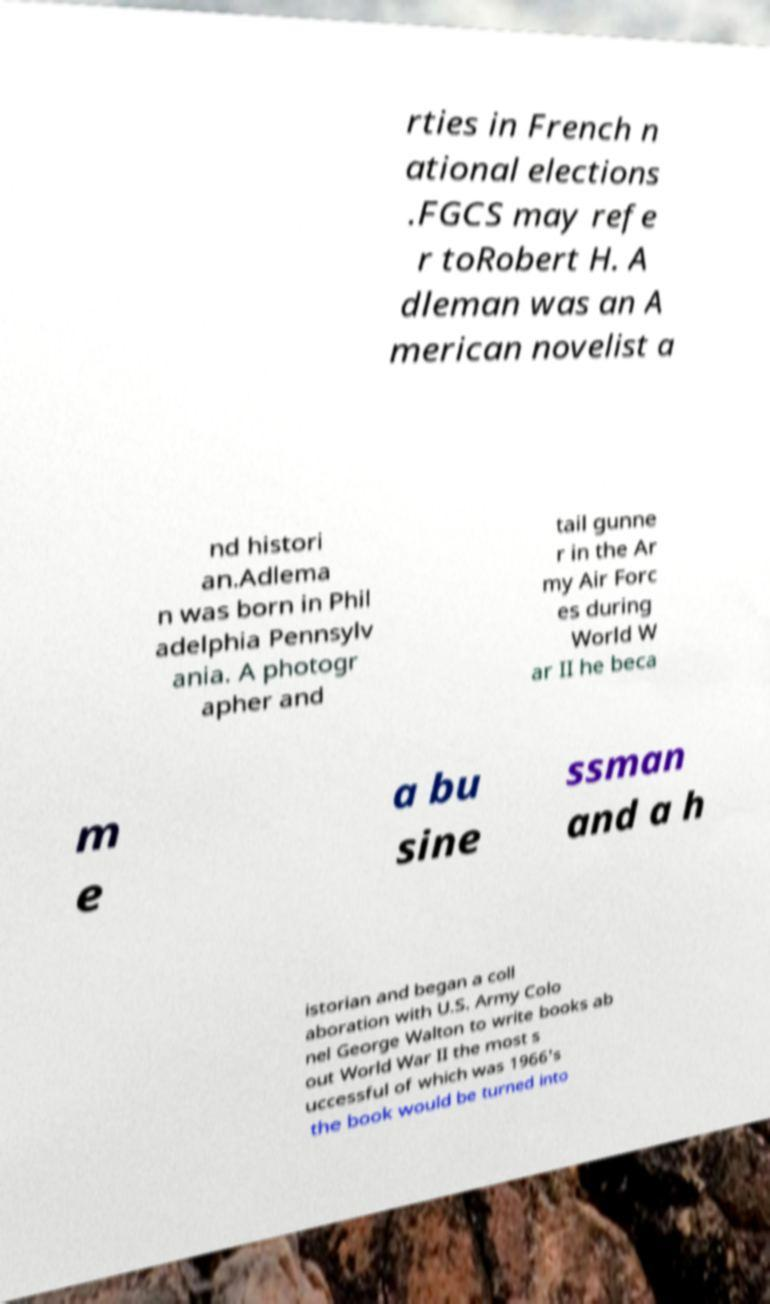Could you assist in decoding the text presented in this image and type it out clearly? rties in French n ational elections .FGCS may refe r toRobert H. A dleman was an A merican novelist a nd histori an.Adlema n was born in Phil adelphia Pennsylv ania. A photogr apher and tail gunne r in the Ar my Air Forc es during World W ar II he beca m e a bu sine ssman and a h istorian and began a coll aboration with U.S. Army Colo nel George Walton to write books ab out World War II the most s uccessful of which was 1966's the book would be turned into 